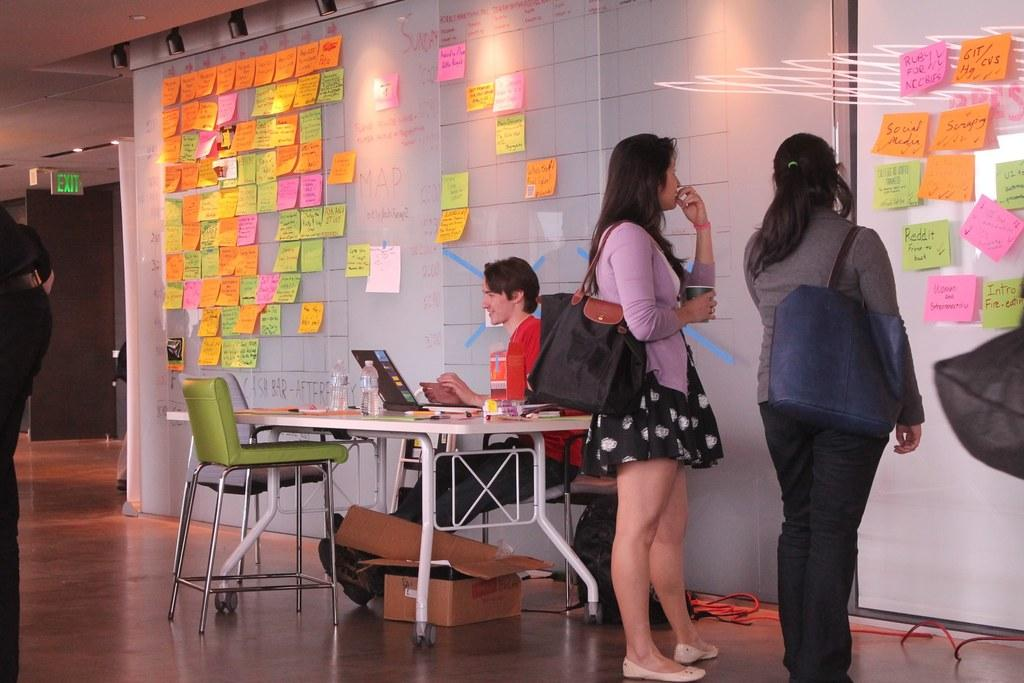What is the person in the image doing? The person is sitting on a chair in the image. Where is the person located in relation to other objects? The person is near a table in the image. What are the two ladies doing in the image? The two ladies are standing near a bulletin board in the image. What is the color of the floor in the image? The floor is brown in color. How many lizards are crawling on the person's chair in the image? There are no lizards present in the image; the person is sitting on a chair without any lizards. What question is being asked by the person sitting on the chair in the image? There is no question being asked by the person sitting on the chair in the image; the image does not show any text or dialogue. 